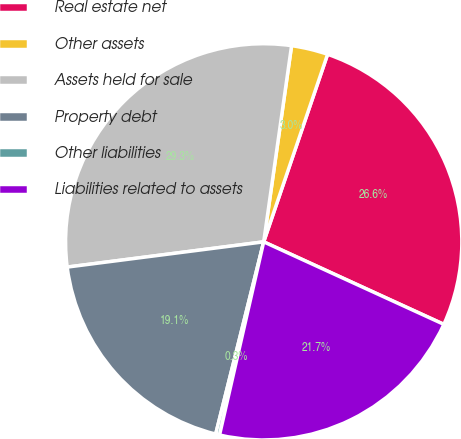Convert chart to OTSL. <chart><loc_0><loc_0><loc_500><loc_500><pie_chart><fcel>Real estate net<fcel>Other assets<fcel>Assets held for sale<fcel>Property debt<fcel>Other liabilities<fcel>Liabilities related to assets<nl><fcel>26.61%<fcel>2.98%<fcel>29.28%<fcel>19.07%<fcel>0.32%<fcel>21.74%<nl></chart> 